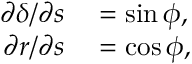Convert formula to latex. <formula><loc_0><loc_0><loc_500><loc_500>\begin{array} { r l } { { \partial \delta } / { \partial s } } & = \sin \phi , } \\ { { \partial r } / { \partial s } } & = \cos \phi , } \end{array}</formula> 